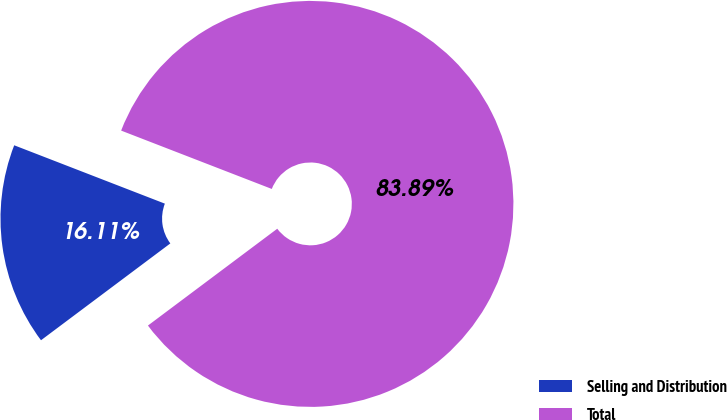Convert chart to OTSL. <chart><loc_0><loc_0><loc_500><loc_500><pie_chart><fcel>Selling and Distribution<fcel>Total<nl><fcel>16.11%<fcel>83.89%<nl></chart> 